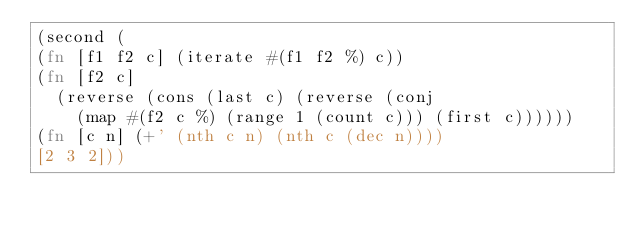<code> <loc_0><loc_0><loc_500><loc_500><_Clojure_>(second (
(fn [f1 f2 c] (iterate #(f1 f2 %) c))
(fn [f2 c]
  (reverse (cons (last c) (reverse (conj
    (map #(f2 c %) (range 1 (count c))) (first c))))))
(fn [c n] (+' (nth c n) (nth c (dec n))))
[2 3 2]))
</code> 